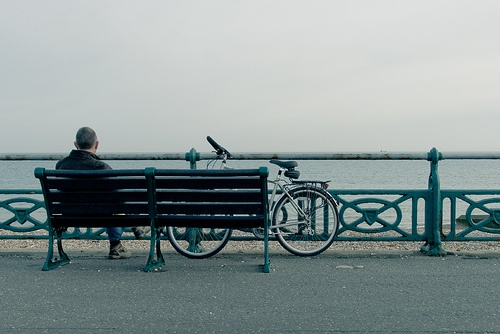Describe the objects in this image and their specific colors. I can see bench in lightgray, black, teal, and darkblue tones, bicycle in lightgray, darkgray, black, gray, and teal tones, and people in lightgray, black, gray, blue, and darkblue tones in this image. 